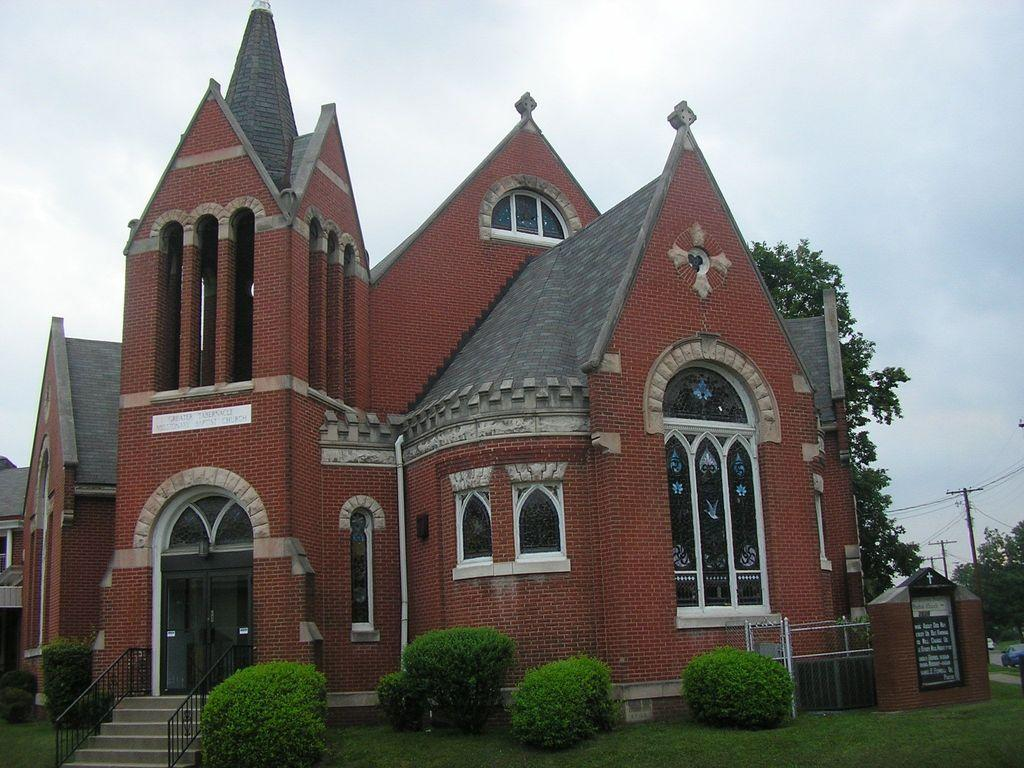What type of house is in the image? There is a brick house in the image. What architectural feature is present near the house? There are steps in the image. What type of vegetation can be seen in the image? There is grass, shrubs, and trees in the image. What utility infrastructure is visible in the image? Current poles and wires are present in the image. What is happening on the road in the image? Vehicles are moving on the road in the image. What can be seen in the background of the image? The sky is visible in the background of the image. Reasoning: Let's think step by step by breaking down the image into its main components. We start by identifying the type of house, which is a brick house. Then, we describe the architectural features, such as the steps. Next, we mention the vegetation, including grass, shrubs, and trees. We also acknowledge the utility infrastructure, which consists of current poles and wires. We then describe the activity on the road, which is the movement of vehicles. Finally, we mention the background, which is the sky. Absurd Question/Answer: Where is the chicken playing during recess in the image? There is no chicken or recess present in the image. What tool is being used to tighten the wrench in the image? There is no wrench or tool usage depicted in the image. 